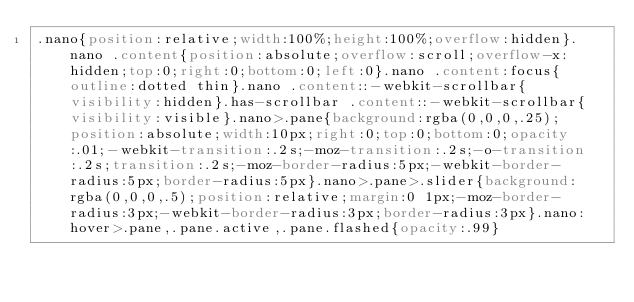<code> <loc_0><loc_0><loc_500><loc_500><_CSS_>.nano{position:relative;width:100%;height:100%;overflow:hidden}.nano .content{position:absolute;overflow:scroll;overflow-x:hidden;top:0;right:0;bottom:0;left:0}.nano .content:focus{outline:dotted thin}.nano .content::-webkit-scrollbar{visibility:hidden}.has-scrollbar .content::-webkit-scrollbar{visibility:visible}.nano>.pane{background:rgba(0,0,0,.25);position:absolute;width:10px;right:0;top:0;bottom:0;opacity:.01;-webkit-transition:.2s;-moz-transition:.2s;-o-transition:.2s;transition:.2s;-moz-border-radius:5px;-webkit-border-radius:5px;border-radius:5px}.nano>.pane>.slider{background:rgba(0,0,0,.5);position:relative;margin:0 1px;-moz-border-radius:3px;-webkit-border-radius:3px;border-radius:3px}.nano:hover>.pane,.pane.active,.pane.flashed{opacity:.99}</code> 